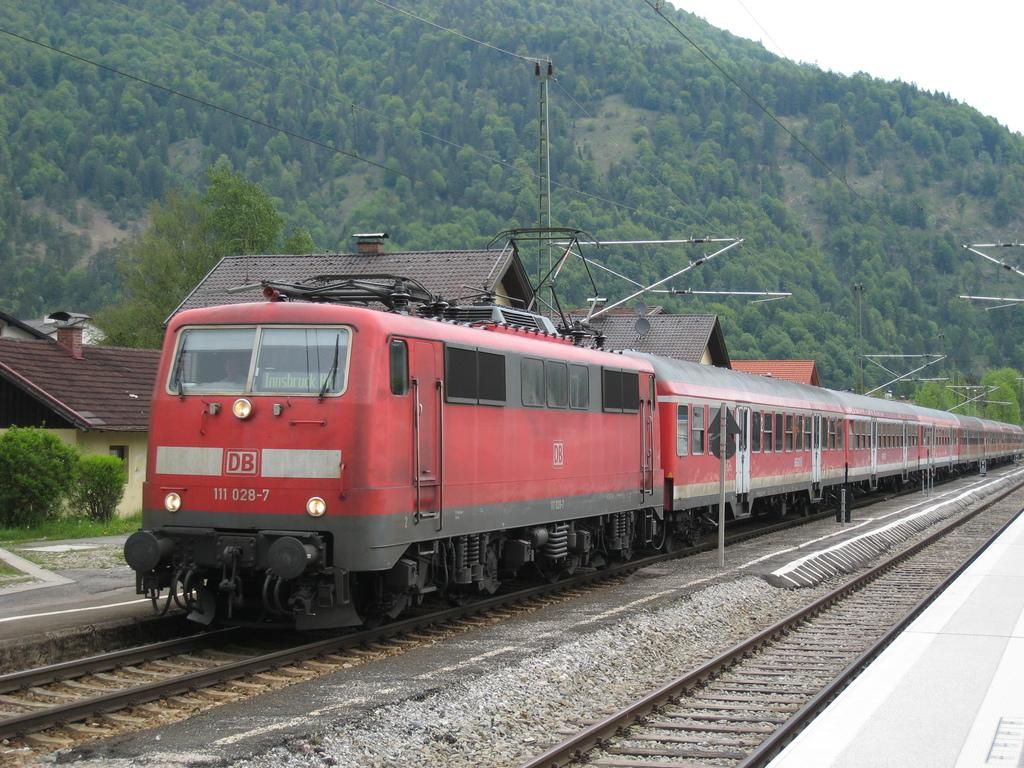What is the number on the front of the red train?
Offer a terse response. 111 028-7. What is the word under the numbers on the front of this train?
Your answer should be compact. Unanswerable. 